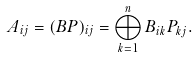<formula> <loc_0><loc_0><loc_500><loc_500>A _ { i j } = ( B P ) _ { i j } = \bigoplus _ { k = 1 } ^ { n } B _ { i k } P _ { k j } .</formula> 